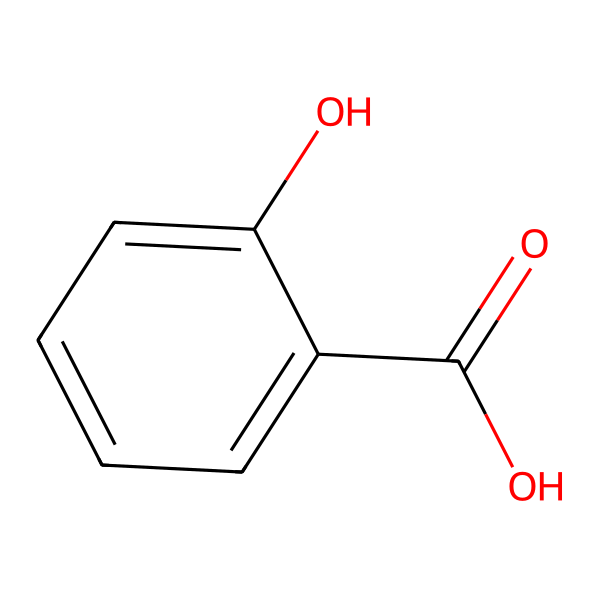What is the molecular formula of this chemical? To derive the molecular formula, count the number of each type of atom present in the structure. The structure has 7 carbon (C) atoms, 6 hydrogen (H) atoms, and 3 oxygen (O) atoms. Combining these gives us the molecular formula C7H6O3.
Answer: C7H6O3 How many hydroxyl (–OH) groups are present? By examining the structure, we can identify the –OH groups. In the chemical structure of salicylic acid, there are two hydroxyl groups: one on the aromatic ring and one as part of the carboxylic acid.
Answer: 2 What functional groups are present in salicylic acid? Functional groups can be identified from the structure. Salicylic acid contains a carboxylic acid group (–COOH) and two hydroxyl groups (–OH).
Answer: carboxylic acid and hydroxyl How does the structure influence its effectiveness in treating acne? Analyzing the structure shows that the presence of the hydroxyl groups provides solubility in water, and the carboxylic acid group contributes to its exfoliating properties. Together, these allow the chemical to penetrate the pores and remove dead skin cells, making it effective against acne.
Answer: penetrates pores and exfoliates What type of acid is salicylic acid? Looking at the carboxylic acid group (–COOH) in the structure tells us that salicylic acid is classified as a weak organic acid.
Answer: weak organic acid How many rings are in the structure? Inspecting the structure reveals that there is one aromatic ring in salicylic acid, which consists of a six-membered carbon ring.
Answer: 1 Is salicylic acid hydrophilic or hydrophobic? By evaluating the functional groups, particularly the presence of hydroxyl (-OH) groups, we can conclude that salicylic acid is hydrophilic, allowing it to interact well with water.
Answer: hydrophilic 